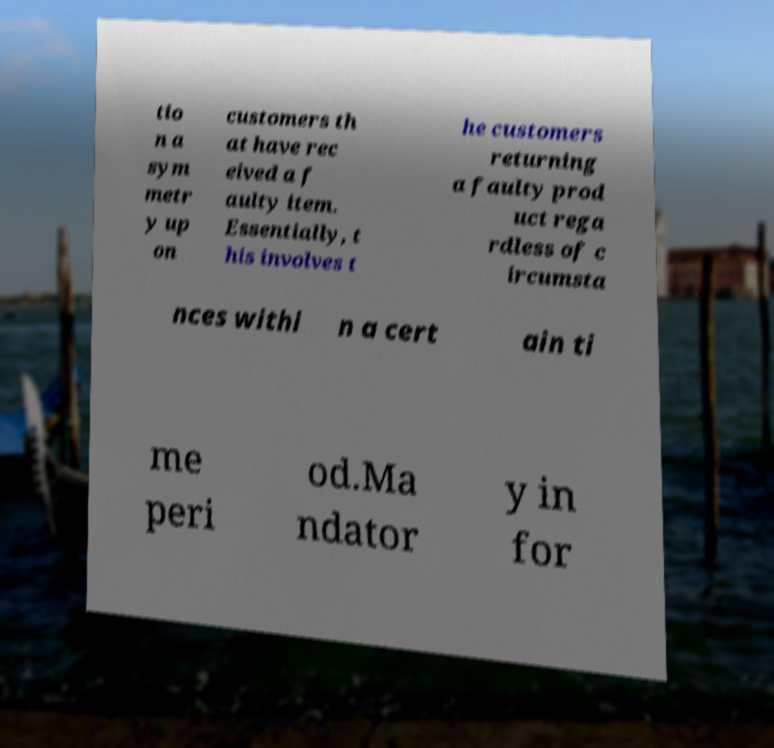There's text embedded in this image that I need extracted. Can you transcribe it verbatim? tio n a sym metr y up on customers th at have rec eived a f aulty item. Essentially, t his involves t he customers returning a faulty prod uct rega rdless of c ircumsta nces withi n a cert ain ti me peri od.Ma ndator y in for 